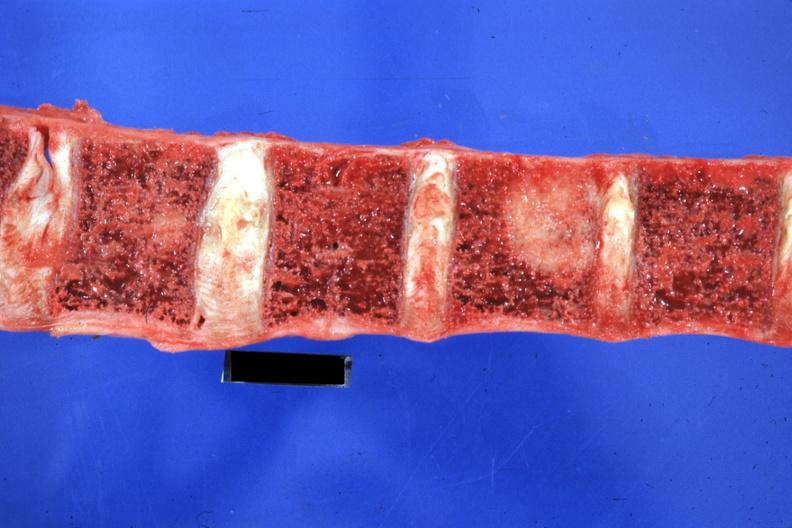s joints present?
Answer the question using a single word or phrase. Yes 